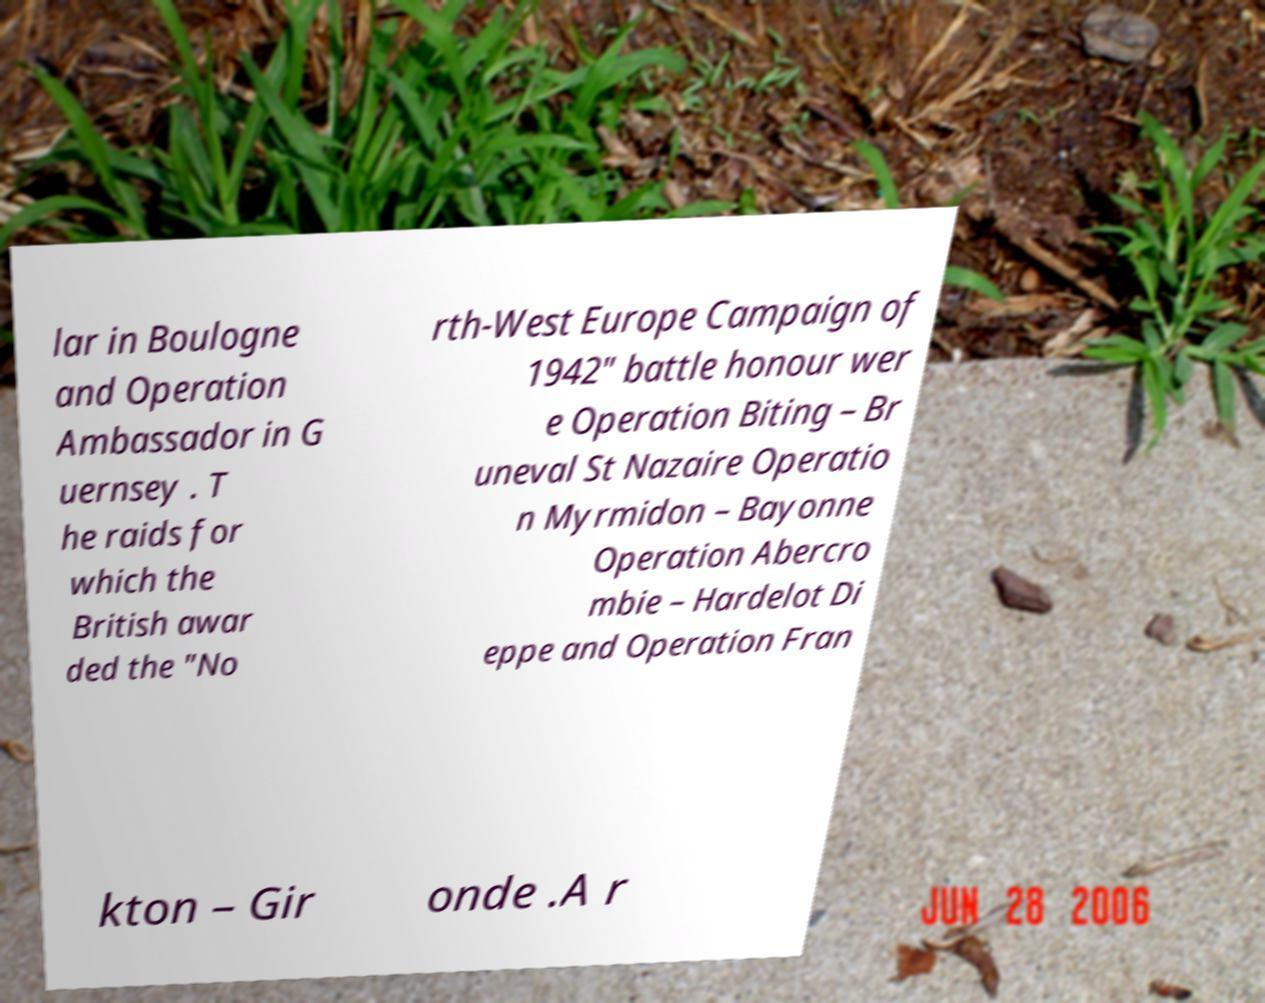There's text embedded in this image that I need extracted. Can you transcribe it verbatim? lar in Boulogne and Operation Ambassador in G uernsey . T he raids for which the British awar ded the "No rth-West Europe Campaign of 1942" battle honour wer e Operation Biting – Br uneval St Nazaire Operatio n Myrmidon – Bayonne Operation Abercro mbie – Hardelot Di eppe and Operation Fran kton – Gir onde .A r 